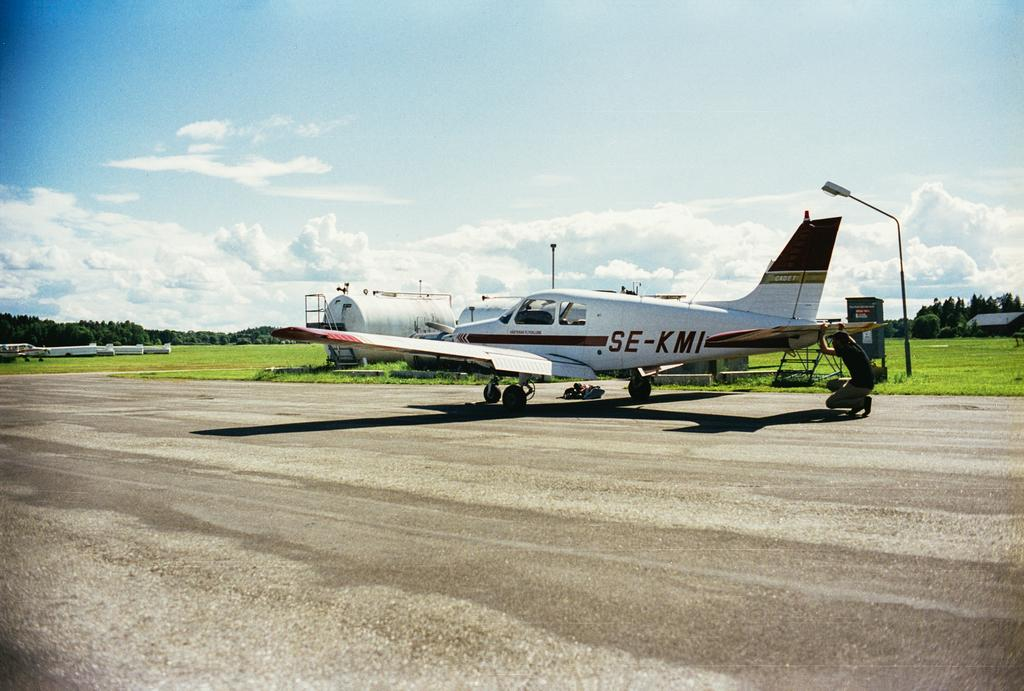Provide a one-sentence caption for the provided image. A small plane sitting on a runway that has the reg number SE-KMI. 